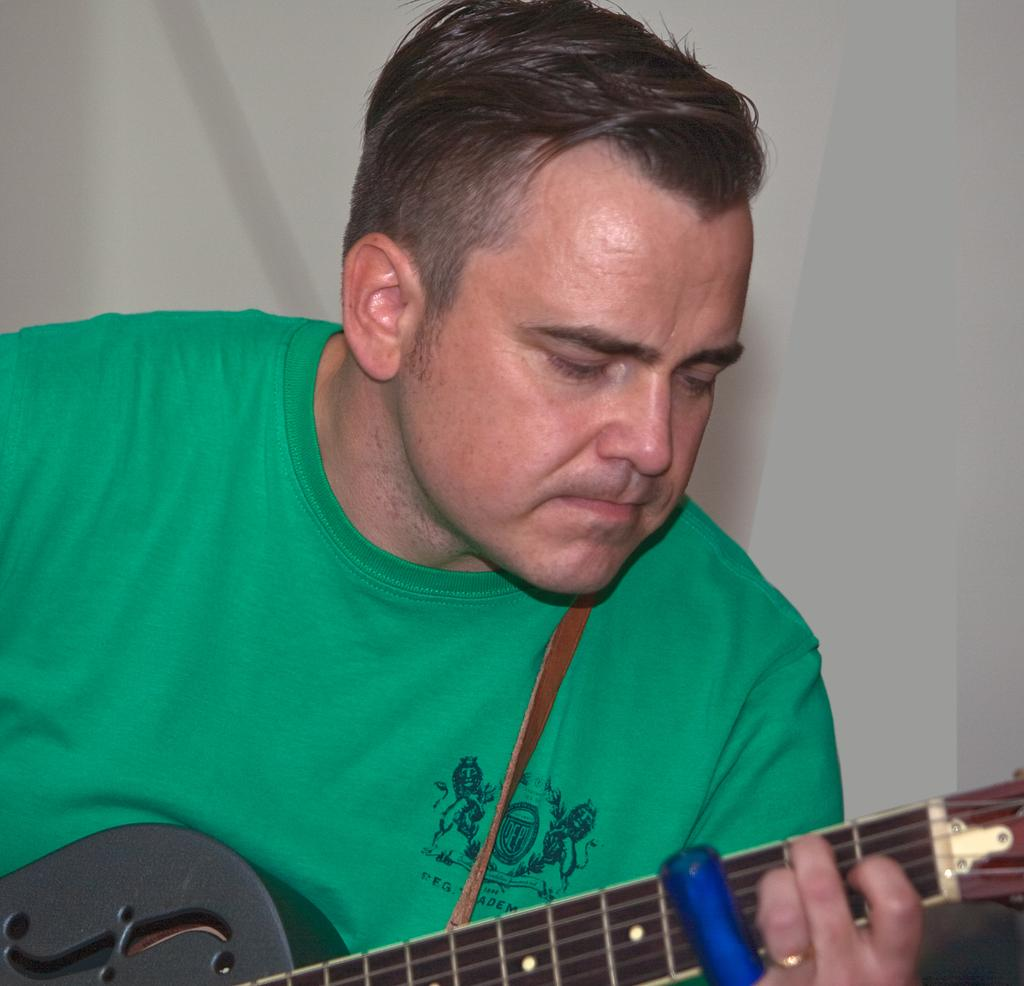What is the main subject of the image? There is a person in the image. What is the person wearing? The person is wearing a green shirt. What object is the person holding? The person is holding a guitar. What is the person doing with the guitar? The person is playing the guitar. How many dogs are sitting on the cake in the image? There is no cake or dogs present in the image. 